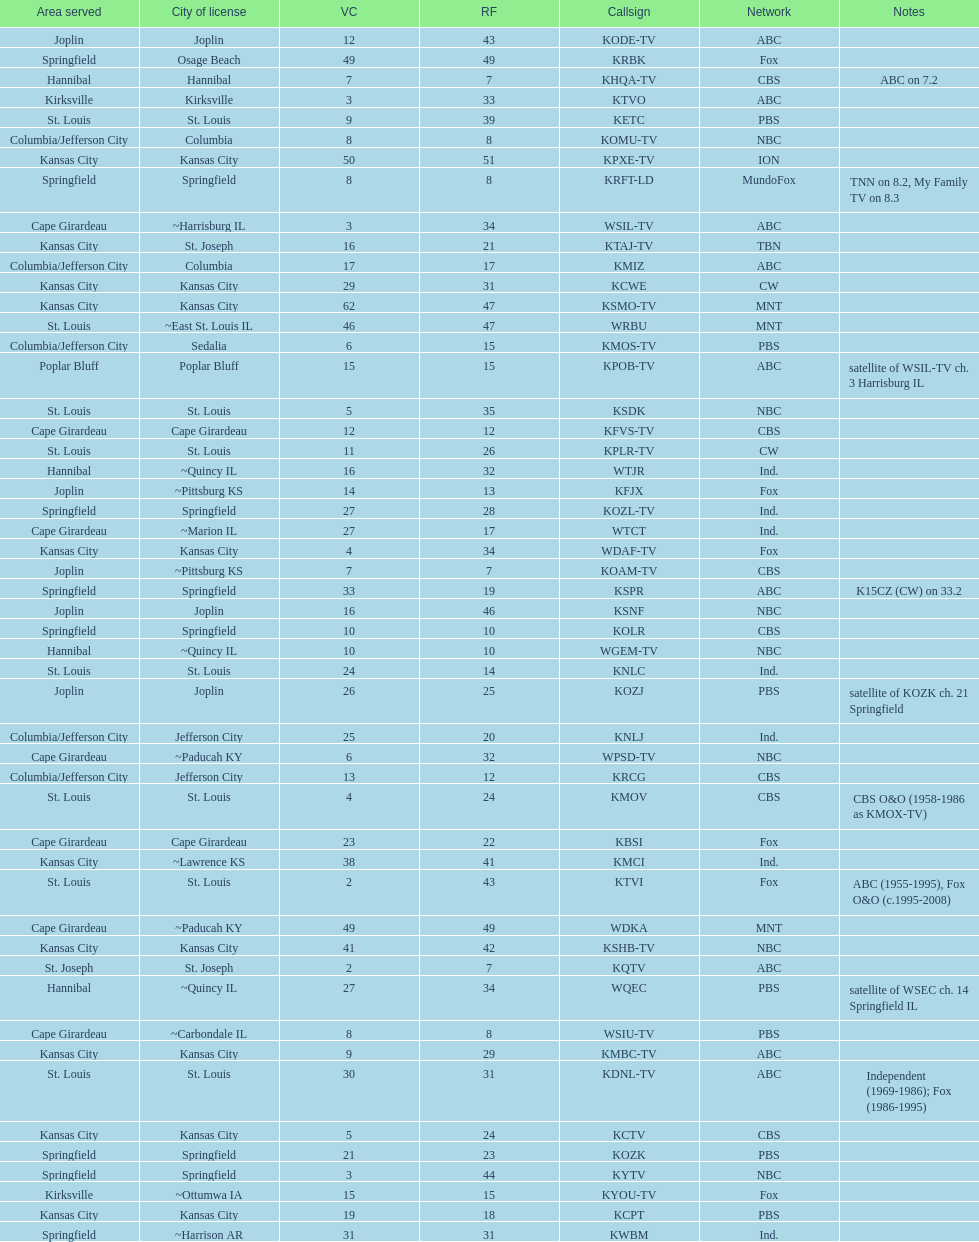What is the total number of stations serving the the cape girardeau area? 7. 